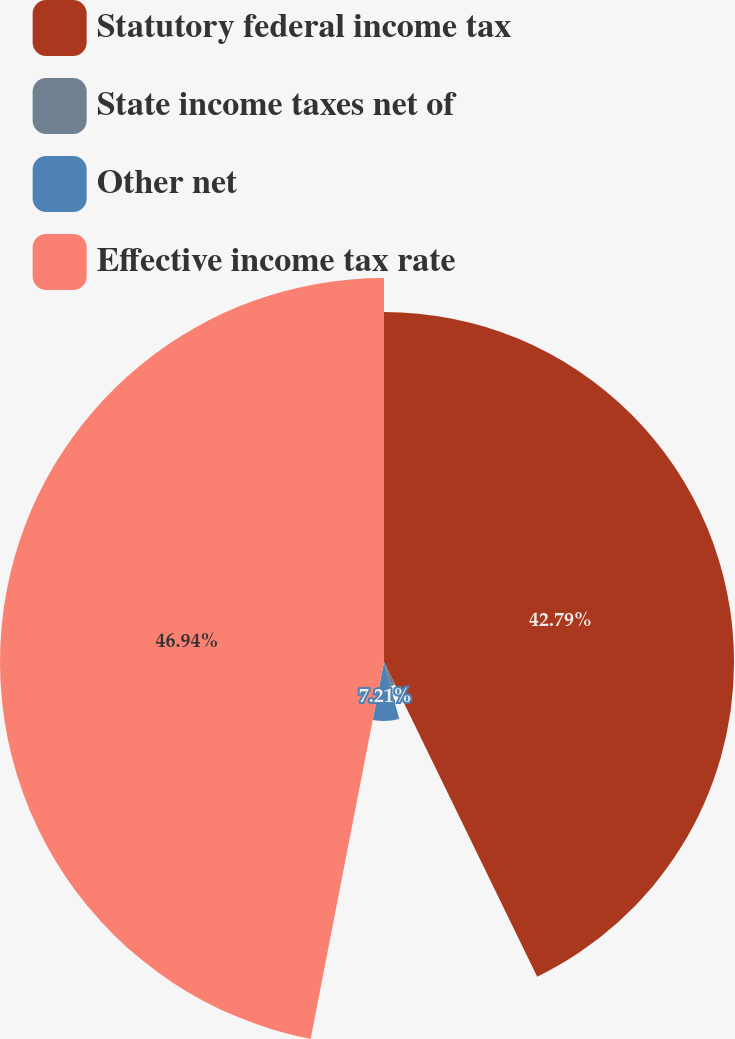Convert chart to OTSL. <chart><loc_0><loc_0><loc_500><loc_500><pie_chart><fcel>Statutory federal income tax<fcel>State income taxes net of<fcel>Other net<fcel>Effective income tax rate<nl><fcel>42.79%<fcel>3.06%<fcel>7.21%<fcel>46.94%<nl></chart> 